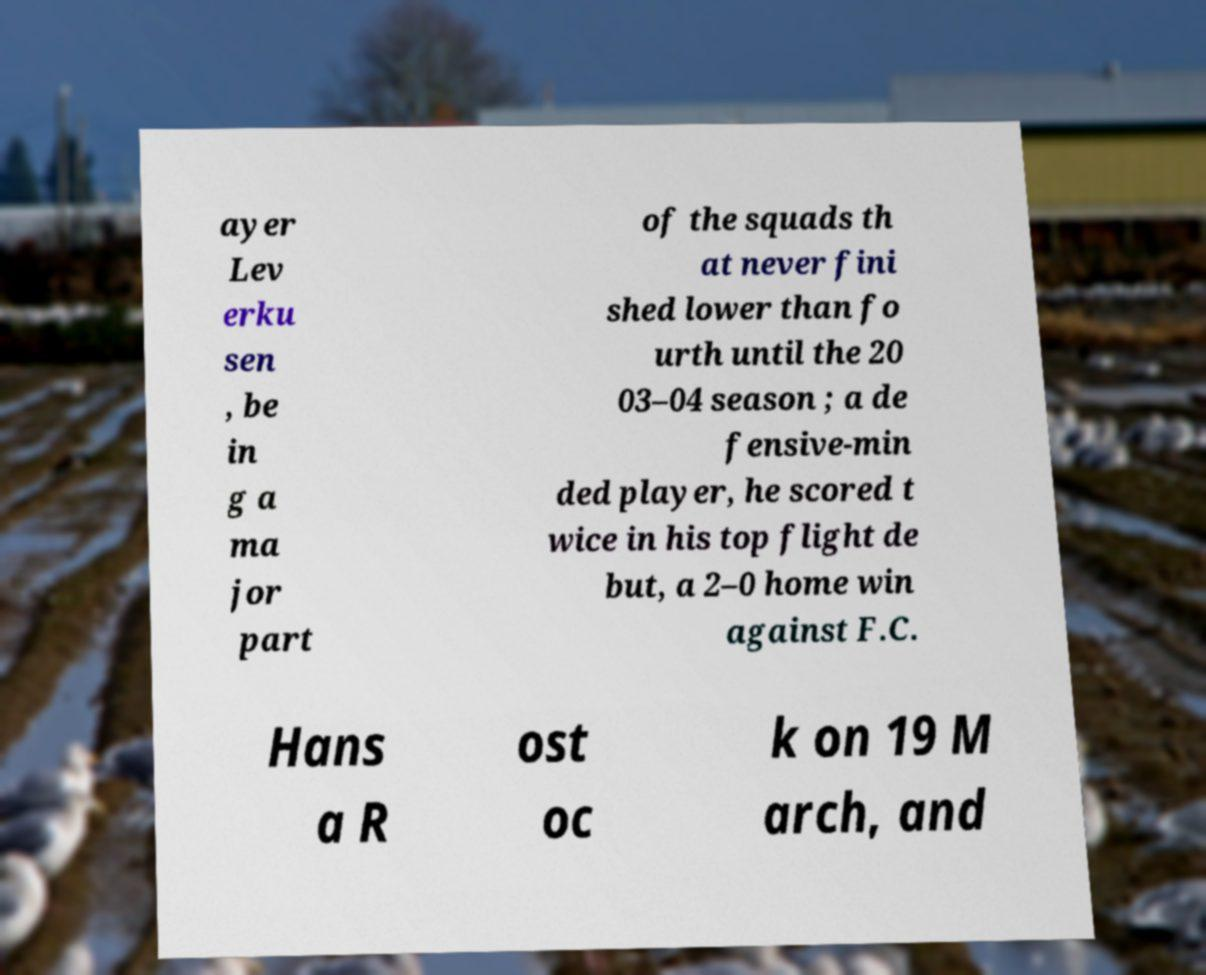Can you read and provide the text displayed in the image?This photo seems to have some interesting text. Can you extract and type it out for me? ayer Lev erku sen , be in g a ma jor part of the squads th at never fini shed lower than fo urth until the 20 03–04 season ; a de fensive-min ded player, he scored t wice in his top flight de but, a 2–0 home win against F.C. Hans a R ost oc k on 19 M arch, and 